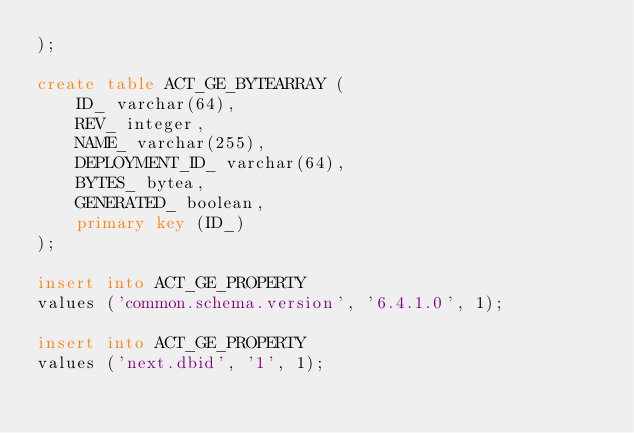<code> <loc_0><loc_0><loc_500><loc_500><_SQL_>);

create table ACT_GE_BYTEARRAY (
    ID_ varchar(64),
    REV_ integer,
    NAME_ varchar(255),
    DEPLOYMENT_ID_ varchar(64),
    BYTES_ bytea,
    GENERATED_ boolean,
    primary key (ID_)
);

insert into ACT_GE_PROPERTY
values ('common.schema.version', '6.4.1.0', 1);

insert into ACT_GE_PROPERTY
values ('next.dbid', '1', 1);
</code> 